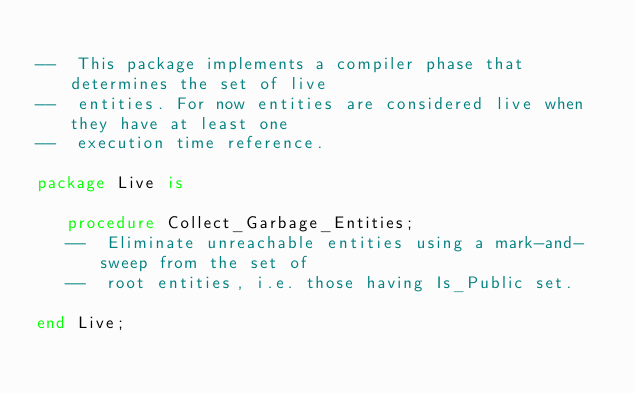<code> <loc_0><loc_0><loc_500><loc_500><_Ada_>
--  This package implements a compiler phase that determines the set of live
--  entities. For now entities are considered live when they have at least one
--  execution time reference.

package Live is

   procedure Collect_Garbage_Entities;
   --  Eliminate unreachable entities using a mark-and-sweep from the set of
   --  root entities, i.e. those having Is_Public set.

end Live;
</code> 